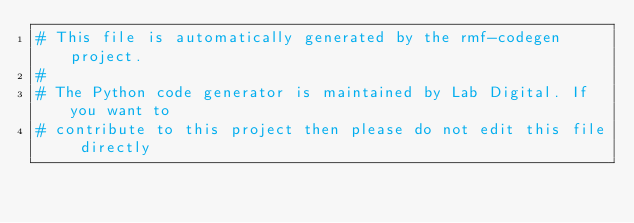Convert code to text. <code><loc_0><loc_0><loc_500><loc_500><_Python_># This file is automatically generated by the rmf-codegen project.
#
# The Python code generator is maintained by Lab Digital. If you want to
# contribute to this project then please do not edit this file directly</code> 